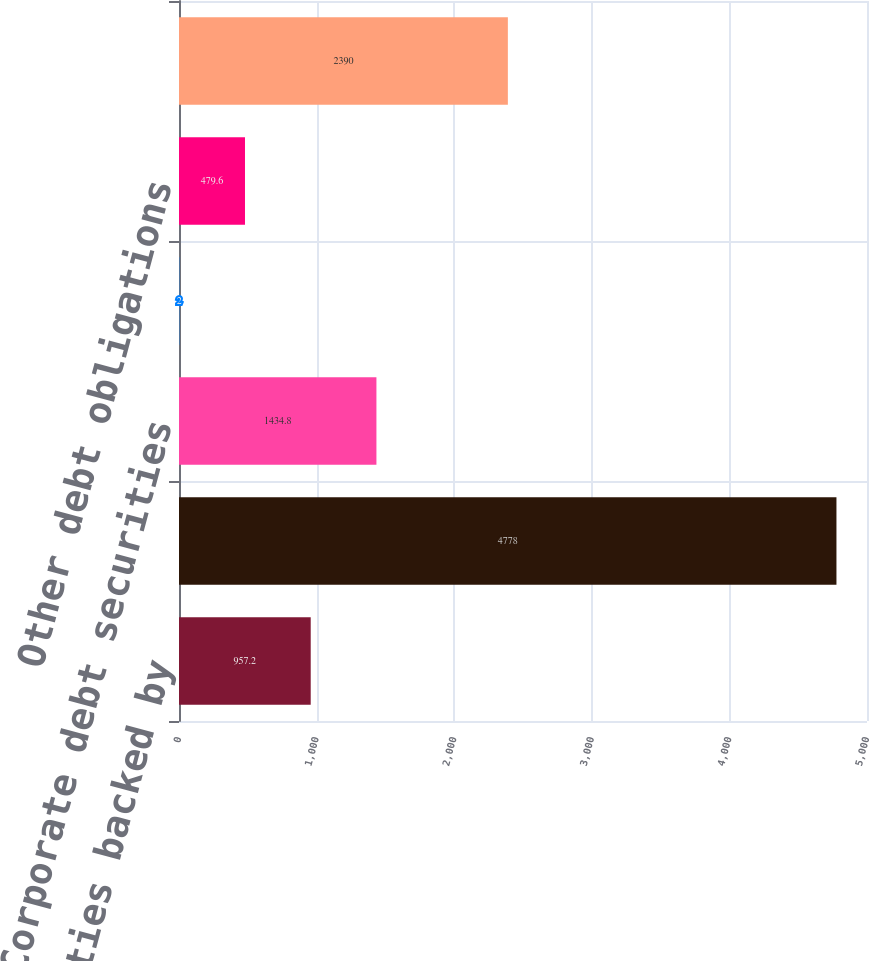Convert chart to OTSL. <chart><loc_0><loc_0><loc_500><loc_500><bar_chart><fcel>Loans and securities backed by<fcel>Bank loans and bridge loans<fcel>Corporate debt securities<fcel>State and municipal<fcel>Other debt obligations<fcel>Equities and convertible<nl><fcel>957.2<fcel>4778<fcel>1434.8<fcel>2<fcel>479.6<fcel>2390<nl></chart> 